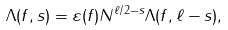Convert formula to latex. <formula><loc_0><loc_0><loc_500><loc_500>\Lambda ( f , s ) = \varepsilon ( f ) N ^ { \ell / 2 - s } \Lambda ( f , \ell - s ) ,</formula> 